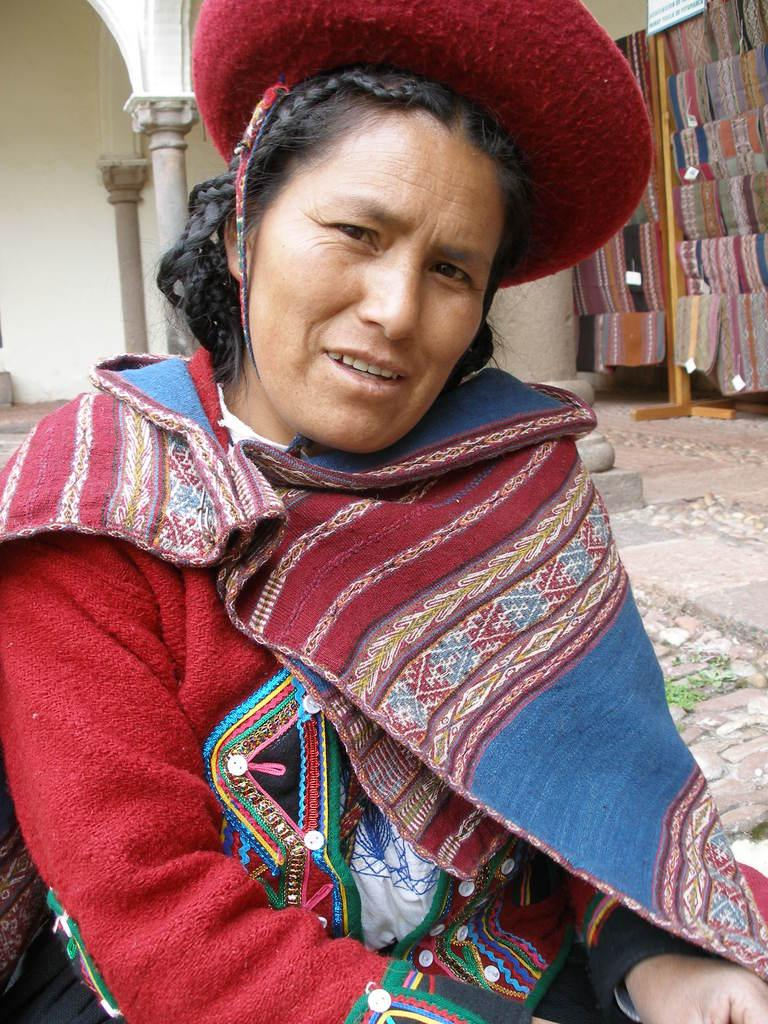Who is the main subject in the image? There is a woman in the image. What is the woman doing in the image? The woman is posing for a camera. What can be seen in the background of the image? There are pillars, clothes, and a wall visible in the background of the image. How many clocks are hanging on the wall in the image? There is no clock visible in the image; only pillars, clothes, and a wall can be seen in the background. Can you see an airplane in the image? There is no airplane present in the image. 